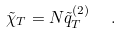<formula> <loc_0><loc_0><loc_500><loc_500>\tilde { \chi } _ { T } = N \tilde { q } ^ { ( 2 ) } _ { T } \ \ .</formula> 